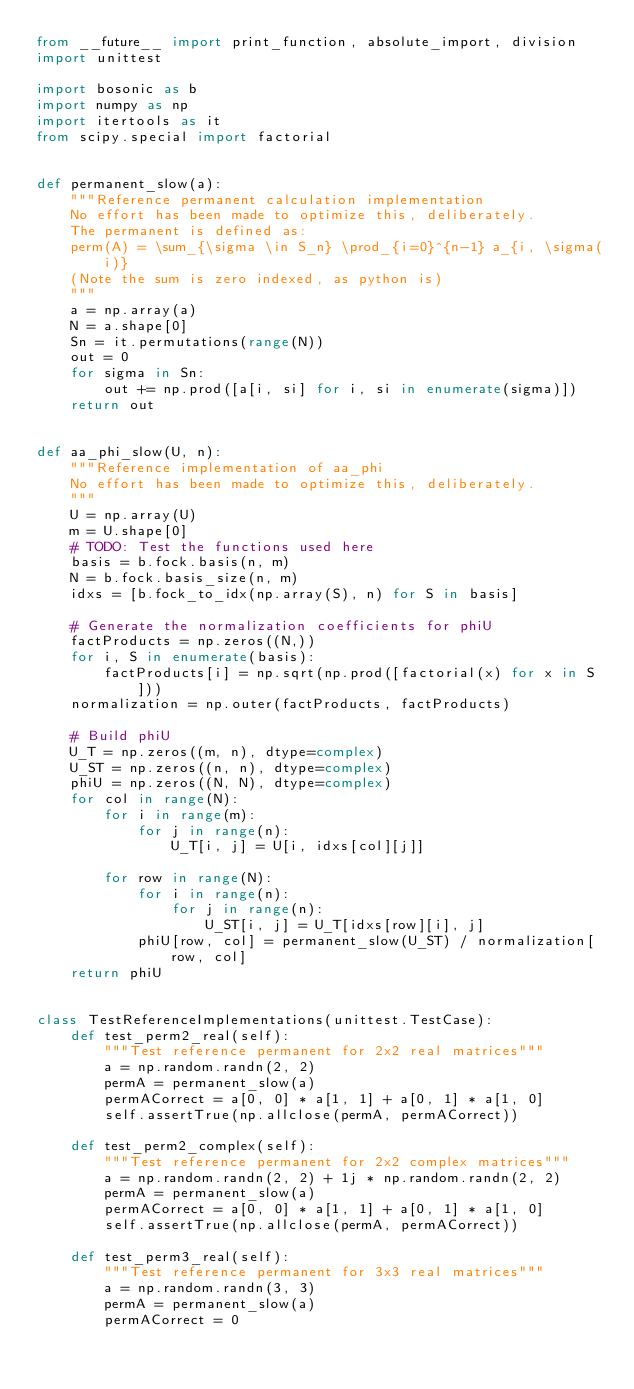Convert code to text. <code><loc_0><loc_0><loc_500><loc_500><_Python_>from __future__ import print_function, absolute_import, division
import unittest

import bosonic as b
import numpy as np
import itertools as it
from scipy.special import factorial


def permanent_slow(a):
    """Reference permanent calculation implementation
    No effort has been made to optimize this, deliberately.
    The permanent is defined as:
    perm(A) = \sum_{\sigma \in S_n} \prod_{i=0}^{n-1} a_{i, \sigma(i)}
    (Note the sum is zero indexed, as python is)
    """
    a = np.array(a)
    N = a.shape[0]
    Sn = it.permutations(range(N))
    out = 0
    for sigma in Sn:
        out += np.prod([a[i, si] for i, si in enumerate(sigma)])
    return out


def aa_phi_slow(U, n):
    """Reference implementation of aa_phi
    No effort has been made to optimize this, deliberately.
    """
    U = np.array(U)
    m = U.shape[0]
    # TODO: Test the functions used here
    basis = b.fock.basis(n, m)
    N = b.fock.basis_size(n, m)
    idxs = [b.fock_to_idx(np.array(S), n) for S in basis]

    # Generate the normalization coefficients for phiU
    factProducts = np.zeros((N,))
    for i, S in enumerate(basis):
        factProducts[i] = np.sqrt(np.prod([factorial(x) for x in S]))
    normalization = np.outer(factProducts, factProducts)

    # Build phiU
    U_T = np.zeros((m, n), dtype=complex)
    U_ST = np.zeros((n, n), dtype=complex)
    phiU = np.zeros((N, N), dtype=complex)
    for col in range(N):
        for i in range(m):
            for j in range(n):
                U_T[i, j] = U[i, idxs[col][j]]

        for row in range(N):
            for i in range(n):
                for j in range(n):
                    U_ST[i, j] = U_T[idxs[row][i], j]
            phiU[row, col] = permanent_slow(U_ST) / normalization[row, col]
    return phiU


class TestReferenceImplementations(unittest.TestCase):
    def test_perm2_real(self):
        """Test reference permanent for 2x2 real matrices"""
        a = np.random.randn(2, 2)
        permA = permanent_slow(a)
        permACorrect = a[0, 0] * a[1, 1] + a[0, 1] * a[1, 0]
        self.assertTrue(np.allclose(permA, permACorrect))

    def test_perm2_complex(self):
        """Test reference permanent for 2x2 complex matrices"""
        a = np.random.randn(2, 2) + 1j * np.random.randn(2, 2)
        permA = permanent_slow(a)
        permACorrect = a[0, 0] * a[1, 1] + a[0, 1] * a[1, 0]
        self.assertTrue(np.allclose(permA, permACorrect))

    def test_perm3_real(self):
        """Test reference permanent for 3x3 real matrices"""
        a = np.random.randn(3, 3)
        permA = permanent_slow(a)
        permACorrect = 0</code> 